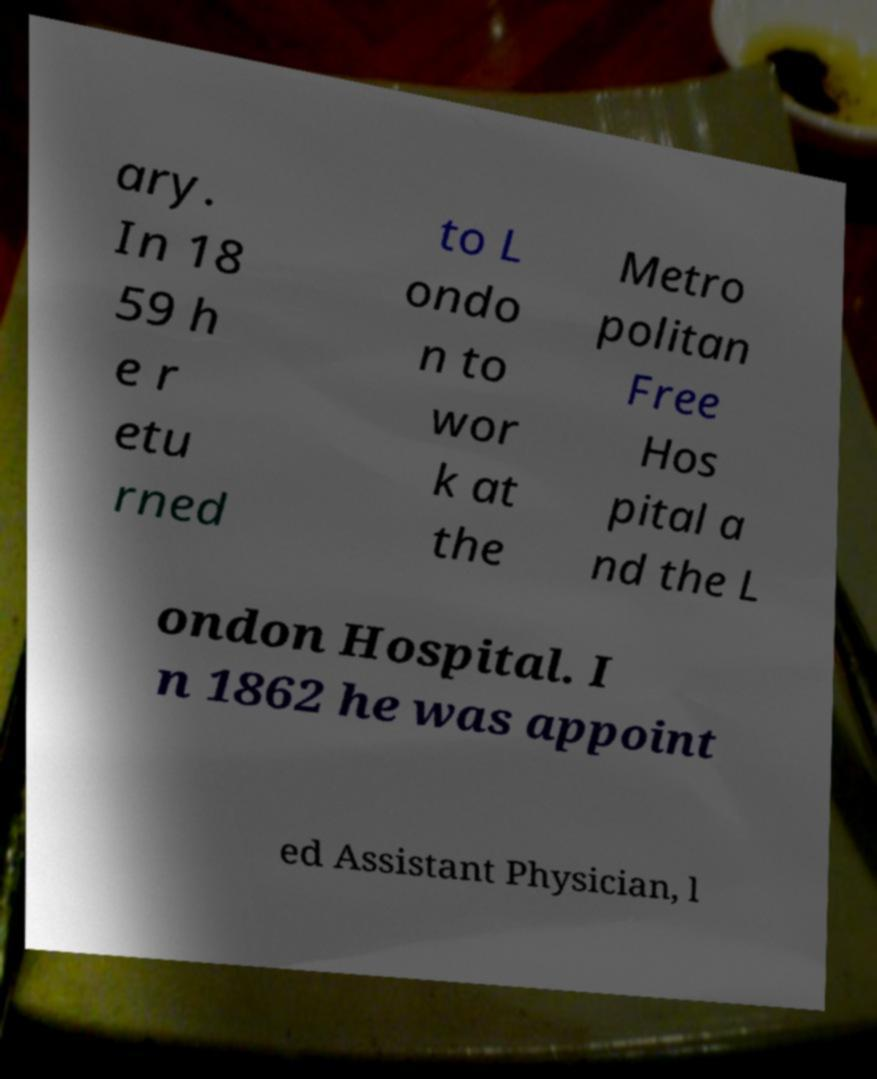Please read and relay the text visible in this image. What does it say? ary. In 18 59 h e r etu rned to L ondo n to wor k at the Metro politan Free Hos pital a nd the L ondon Hospital. I n 1862 he was appoint ed Assistant Physician, l 